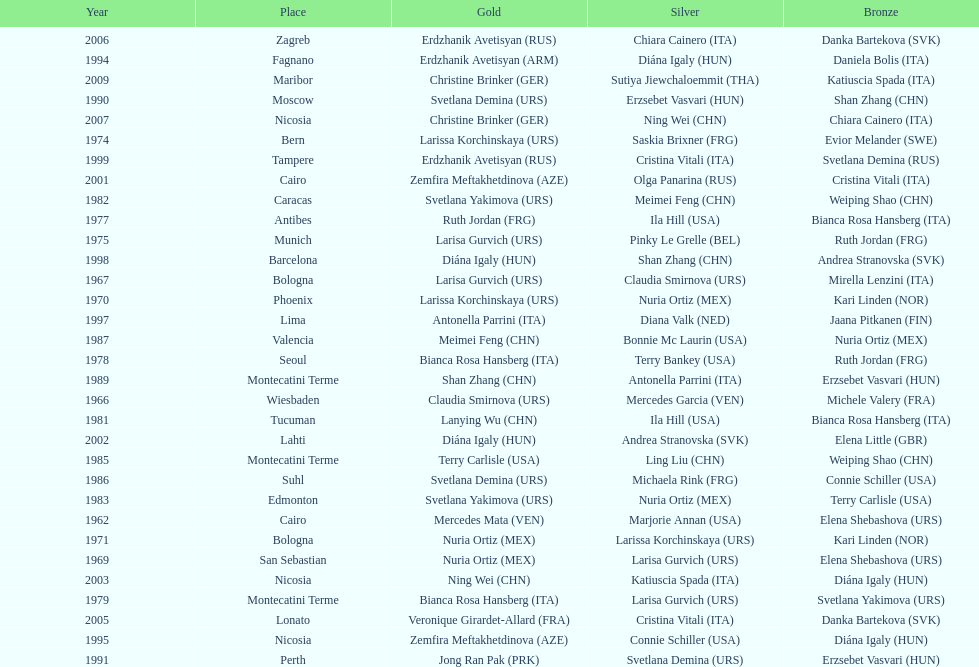Which country has won more gold medals: china or mexico? China. 